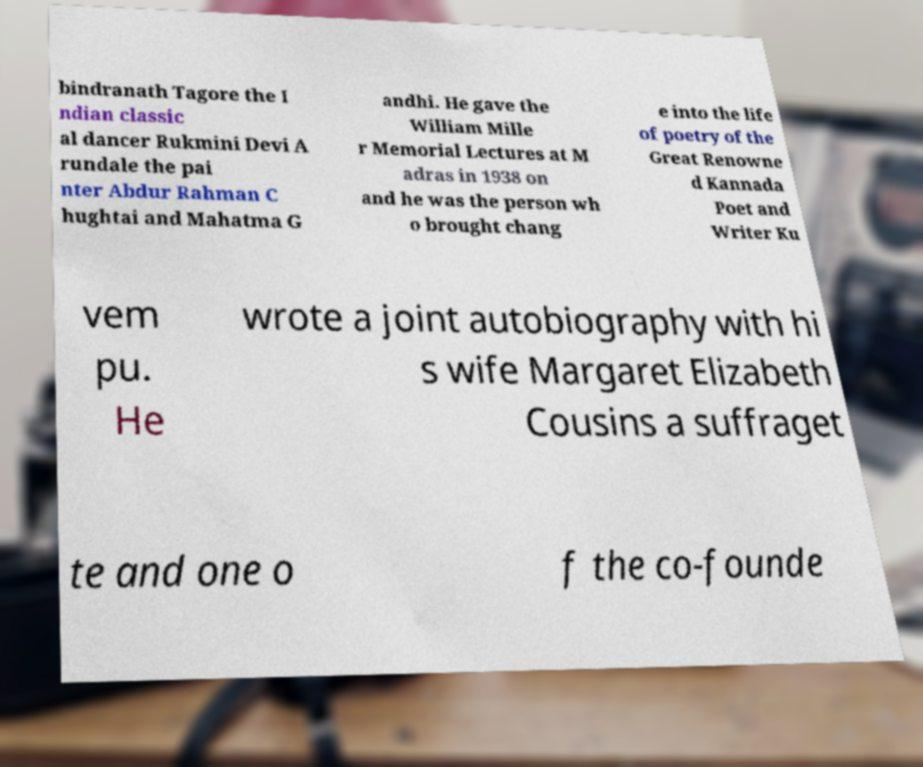Could you assist in decoding the text presented in this image and type it out clearly? bindranath Tagore the I ndian classic al dancer Rukmini Devi A rundale the pai nter Abdur Rahman C hughtai and Mahatma G andhi. He gave the William Mille r Memorial Lectures at M adras in 1938 on and he was the person wh o brought chang e into the life of poetry of the Great Renowne d Kannada Poet and Writer Ku vem pu. He wrote a joint autobiography with hi s wife Margaret Elizabeth Cousins a suffraget te and one o f the co-founde 